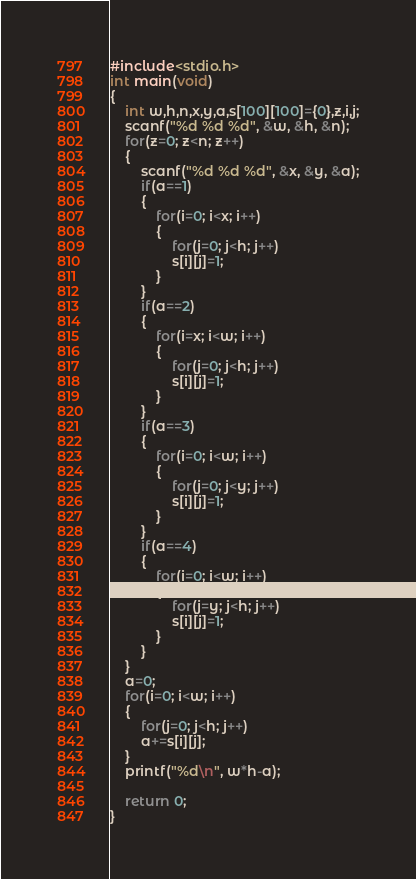<code> <loc_0><loc_0><loc_500><loc_500><_C_>#include<stdio.h>
int main(void)
{
	int w,h,n,x,y,a,s[100][100]={0},z,i,j;
	scanf("%d %d %d", &w, &h, &n);
	for(z=0; z<n; z++)
	{
		scanf("%d %d %d", &x, &y, &a);
		if(a==1)
		{
			for(i=0; i<x; i++)
			{
				for(j=0; j<h; j++)
				s[i][j]=1;
			}
		}
		if(a==2)
		{
			for(i=x; i<w; i++)
			{
				for(j=0; j<h; j++)
				s[i][j]=1;
			}
		}
		if(a==3)
		{
			for(i=0; i<w; i++)
			{
				for(j=0; j<y; j++)
				s[i][j]=1;
			}
		}
		if(a==4)
		{
			for(i=0; i<w; i++)
			{
				for(j=y; j<h; j++)
				s[i][j]=1;
			}
		}
	}
	a=0;
	for(i=0; i<w; i++)
	{
		for(j=0; j<h; j++)
		a+=s[i][j];
	}
	printf("%d\n", w*h-a);
	
	return 0;
}</code> 